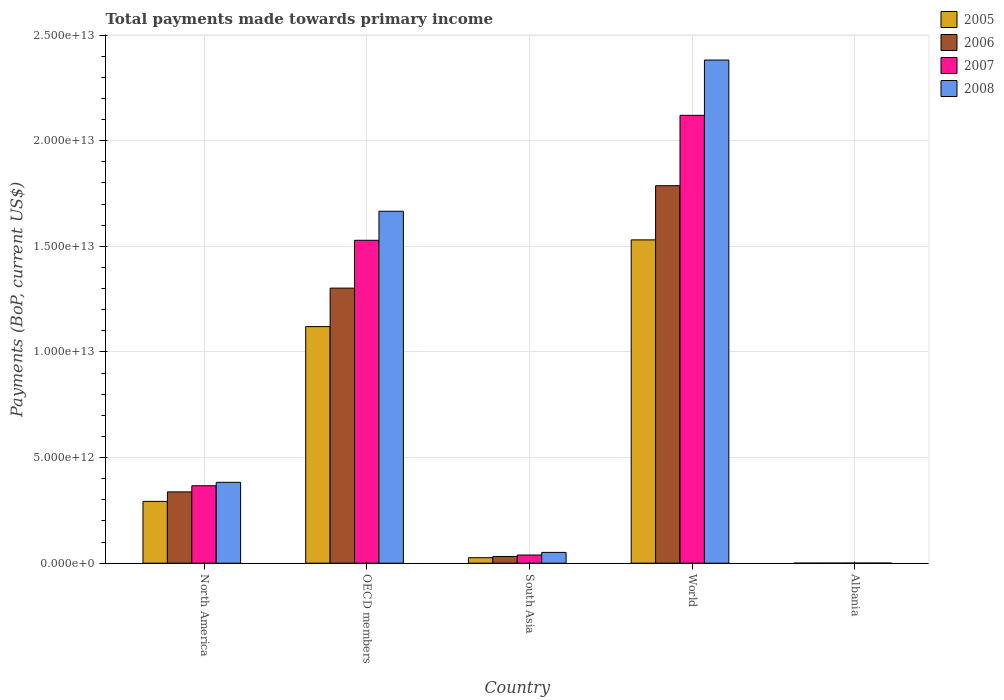How many different coloured bars are there?
Provide a short and direct response. 4. How many groups of bars are there?
Your response must be concise. 5. Are the number of bars per tick equal to the number of legend labels?
Provide a short and direct response. Yes. Are the number of bars on each tick of the X-axis equal?
Your response must be concise. Yes. How many bars are there on the 3rd tick from the left?
Ensure brevity in your answer.  4. How many bars are there on the 5th tick from the right?
Ensure brevity in your answer.  4. What is the label of the 1st group of bars from the left?
Give a very brief answer. North America. In how many cases, is the number of bars for a given country not equal to the number of legend labels?
Provide a succinct answer. 0. What is the total payments made towards primary income in 2007 in World?
Provide a succinct answer. 2.12e+13. Across all countries, what is the maximum total payments made towards primary income in 2005?
Offer a very short reply. 1.53e+13. Across all countries, what is the minimum total payments made towards primary income in 2006?
Offer a very short reply. 4.14e+09. In which country was the total payments made towards primary income in 2007 minimum?
Provide a short and direct response. Albania. What is the total total payments made towards primary income in 2006 in the graph?
Make the answer very short. 3.46e+13. What is the difference between the total payments made towards primary income in 2006 in Albania and that in OECD members?
Ensure brevity in your answer.  -1.30e+13. What is the difference between the total payments made towards primary income in 2007 in World and the total payments made towards primary income in 2006 in North America?
Give a very brief answer. 1.78e+13. What is the average total payments made towards primary income in 2006 per country?
Give a very brief answer. 6.92e+12. What is the difference between the total payments made towards primary income of/in 2007 and total payments made towards primary income of/in 2008 in OECD members?
Your answer should be very brief. -1.38e+12. In how many countries, is the total payments made towards primary income in 2005 greater than 1000000000000 US$?
Provide a short and direct response. 3. What is the ratio of the total payments made towards primary income in 2008 in North America to that in South Asia?
Your answer should be very brief. 7.49. Is the total payments made towards primary income in 2007 in OECD members less than that in World?
Your answer should be compact. Yes. What is the difference between the highest and the second highest total payments made towards primary income in 2007?
Provide a succinct answer. 1.75e+13. What is the difference between the highest and the lowest total payments made towards primary income in 2005?
Provide a short and direct response. 1.53e+13. Is it the case that in every country, the sum of the total payments made towards primary income in 2005 and total payments made towards primary income in 2008 is greater than the total payments made towards primary income in 2007?
Provide a short and direct response. Yes. What is the difference between two consecutive major ticks on the Y-axis?
Give a very brief answer. 5.00e+12. Does the graph contain any zero values?
Your answer should be very brief. No. Where does the legend appear in the graph?
Provide a short and direct response. Top right. What is the title of the graph?
Your answer should be very brief. Total payments made towards primary income. What is the label or title of the Y-axis?
Offer a very short reply. Payments (BoP, current US$). What is the Payments (BoP, current US$) of 2005 in North America?
Your answer should be very brief. 2.93e+12. What is the Payments (BoP, current US$) of 2006 in North America?
Provide a short and direct response. 3.38e+12. What is the Payments (BoP, current US$) of 2007 in North America?
Your answer should be compact. 3.67e+12. What is the Payments (BoP, current US$) in 2008 in North America?
Offer a very short reply. 3.83e+12. What is the Payments (BoP, current US$) in 2005 in OECD members?
Your response must be concise. 1.12e+13. What is the Payments (BoP, current US$) in 2006 in OECD members?
Provide a succinct answer. 1.30e+13. What is the Payments (BoP, current US$) of 2007 in OECD members?
Give a very brief answer. 1.53e+13. What is the Payments (BoP, current US$) of 2008 in OECD members?
Offer a very short reply. 1.67e+13. What is the Payments (BoP, current US$) in 2005 in South Asia?
Offer a very short reply. 2.61e+11. What is the Payments (BoP, current US$) of 2006 in South Asia?
Ensure brevity in your answer.  3.18e+11. What is the Payments (BoP, current US$) of 2007 in South Asia?
Your answer should be very brief. 3.88e+11. What is the Payments (BoP, current US$) in 2008 in South Asia?
Your answer should be compact. 5.11e+11. What is the Payments (BoP, current US$) of 2005 in World?
Offer a terse response. 1.53e+13. What is the Payments (BoP, current US$) of 2006 in World?
Offer a very short reply. 1.79e+13. What is the Payments (BoP, current US$) of 2007 in World?
Make the answer very short. 2.12e+13. What is the Payments (BoP, current US$) in 2008 in World?
Offer a terse response. 2.38e+13. What is the Payments (BoP, current US$) in 2005 in Albania?
Your response must be concise. 3.55e+09. What is the Payments (BoP, current US$) in 2006 in Albania?
Provide a succinct answer. 4.14e+09. What is the Payments (BoP, current US$) in 2007 in Albania?
Make the answer very short. 5.43e+09. What is the Payments (BoP, current US$) in 2008 in Albania?
Your answer should be compact. 7.15e+09. Across all countries, what is the maximum Payments (BoP, current US$) of 2005?
Provide a short and direct response. 1.53e+13. Across all countries, what is the maximum Payments (BoP, current US$) of 2006?
Your answer should be very brief. 1.79e+13. Across all countries, what is the maximum Payments (BoP, current US$) of 2007?
Provide a succinct answer. 2.12e+13. Across all countries, what is the maximum Payments (BoP, current US$) in 2008?
Give a very brief answer. 2.38e+13. Across all countries, what is the minimum Payments (BoP, current US$) of 2005?
Your answer should be compact. 3.55e+09. Across all countries, what is the minimum Payments (BoP, current US$) in 2006?
Keep it short and to the point. 4.14e+09. Across all countries, what is the minimum Payments (BoP, current US$) in 2007?
Give a very brief answer. 5.43e+09. Across all countries, what is the minimum Payments (BoP, current US$) in 2008?
Offer a very short reply. 7.15e+09. What is the total Payments (BoP, current US$) of 2005 in the graph?
Ensure brevity in your answer.  2.97e+13. What is the total Payments (BoP, current US$) in 2006 in the graph?
Provide a short and direct response. 3.46e+13. What is the total Payments (BoP, current US$) of 2007 in the graph?
Provide a succinct answer. 4.05e+13. What is the total Payments (BoP, current US$) in 2008 in the graph?
Ensure brevity in your answer.  4.48e+13. What is the difference between the Payments (BoP, current US$) in 2005 in North America and that in OECD members?
Your response must be concise. -8.27e+12. What is the difference between the Payments (BoP, current US$) in 2006 in North America and that in OECD members?
Your response must be concise. -9.65e+12. What is the difference between the Payments (BoP, current US$) in 2007 in North America and that in OECD members?
Offer a terse response. -1.16e+13. What is the difference between the Payments (BoP, current US$) in 2008 in North America and that in OECD members?
Your answer should be compact. -1.28e+13. What is the difference between the Payments (BoP, current US$) of 2005 in North America and that in South Asia?
Offer a terse response. 2.67e+12. What is the difference between the Payments (BoP, current US$) in 2006 in North America and that in South Asia?
Your response must be concise. 3.06e+12. What is the difference between the Payments (BoP, current US$) in 2007 in North America and that in South Asia?
Offer a terse response. 3.28e+12. What is the difference between the Payments (BoP, current US$) of 2008 in North America and that in South Asia?
Your response must be concise. 3.32e+12. What is the difference between the Payments (BoP, current US$) in 2005 in North America and that in World?
Give a very brief answer. -1.24e+13. What is the difference between the Payments (BoP, current US$) of 2006 in North America and that in World?
Provide a short and direct response. -1.45e+13. What is the difference between the Payments (BoP, current US$) in 2007 in North America and that in World?
Your answer should be very brief. -1.75e+13. What is the difference between the Payments (BoP, current US$) of 2008 in North America and that in World?
Make the answer very short. -2.00e+13. What is the difference between the Payments (BoP, current US$) in 2005 in North America and that in Albania?
Your answer should be compact. 2.92e+12. What is the difference between the Payments (BoP, current US$) in 2006 in North America and that in Albania?
Make the answer very short. 3.37e+12. What is the difference between the Payments (BoP, current US$) of 2007 in North America and that in Albania?
Your answer should be compact. 3.66e+12. What is the difference between the Payments (BoP, current US$) in 2008 in North America and that in Albania?
Give a very brief answer. 3.82e+12. What is the difference between the Payments (BoP, current US$) of 2005 in OECD members and that in South Asia?
Provide a short and direct response. 1.09e+13. What is the difference between the Payments (BoP, current US$) in 2006 in OECD members and that in South Asia?
Your answer should be compact. 1.27e+13. What is the difference between the Payments (BoP, current US$) of 2007 in OECD members and that in South Asia?
Your response must be concise. 1.49e+13. What is the difference between the Payments (BoP, current US$) of 2008 in OECD members and that in South Asia?
Offer a very short reply. 1.61e+13. What is the difference between the Payments (BoP, current US$) in 2005 in OECD members and that in World?
Your response must be concise. -4.11e+12. What is the difference between the Payments (BoP, current US$) in 2006 in OECD members and that in World?
Offer a very short reply. -4.85e+12. What is the difference between the Payments (BoP, current US$) of 2007 in OECD members and that in World?
Your answer should be compact. -5.91e+12. What is the difference between the Payments (BoP, current US$) in 2008 in OECD members and that in World?
Ensure brevity in your answer.  -7.16e+12. What is the difference between the Payments (BoP, current US$) in 2005 in OECD members and that in Albania?
Your answer should be very brief. 1.12e+13. What is the difference between the Payments (BoP, current US$) of 2006 in OECD members and that in Albania?
Your answer should be very brief. 1.30e+13. What is the difference between the Payments (BoP, current US$) in 2007 in OECD members and that in Albania?
Ensure brevity in your answer.  1.53e+13. What is the difference between the Payments (BoP, current US$) of 2008 in OECD members and that in Albania?
Offer a very short reply. 1.67e+13. What is the difference between the Payments (BoP, current US$) in 2005 in South Asia and that in World?
Your answer should be very brief. -1.50e+13. What is the difference between the Payments (BoP, current US$) of 2006 in South Asia and that in World?
Offer a very short reply. -1.75e+13. What is the difference between the Payments (BoP, current US$) of 2007 in South Asia and that in World?
Provide a succinct answer. -2.08e+13. What is the difference between the Payments (BoP, current US$) in 2008 in South Asia and that in World?
Provide a succinct answer. -2.33e+13. What is the difference between the Payments (BoP, current US$) in 2005 in South Asia and that in Albania?
Your response must be concise. 2.57e+11. What is the difference between the Payments (BoP, current US$) of 2006 in South Asia and that in Albania?
Provide a succinct answer. 3.14e+11. What is the difference between the Payments (BoP, current US$) in 2007 in South Asia and that in Albania?
Offer a terse response. 3.82e+11. What is the difference between the Payments (BoP, current US$) of 2008 in South Asia and that in Albania?
Give a very brief answer. 5.04e+11. What is the difference between the Payments (BoP, current US$) of 2005 in World and that in Albania?
Your answer should be compact. 1.53e+13. What is the difference between the Payments (BoP, current US$) of 2006 in World and that in Albania?
Give a very brief answer. 1.79e+13. What is the difference between the Payments (BoP, current US$) of 2007 in World and that in Albania?
Provide a short and direct response. 2.12e+13. What is the difference between the Payments (BoP, current US$) of 2008 in World and that in Albania?
Ensure brevity in your answer.  2.38e+13. What is the difference between the Payments (BoP, current US$) of 2005 in North America and the Payments (BoP, current US$) of 2006 in OECD members?
Your answer should be very brief. -1.01e+13. What is the difference between the Payments (BoP, current US$) in 2005 in North America and the Payments (BoP, current US$) in 2007 in OECD members?
Your answer should be compact. -1.24e+13. What is the difference between the Payments (BoP, current US$) of 2005 in North America and the Payments (BoP, current US$) of 2008 in OECD members?
Provide a short and direct response. -1.37e+13. What is the difference between the Payments (BoP, current US$) of 2006 in North America and the Payments (BoP, current US$) of 2007 in OECD members?
Your response must be concise. -1.19e+13. What is the difference between the Payments (BoP, current US$) in 2006 in North America and the Payments (BoP, current US$) in 2008 in OECD members?
Ensure brevity in your answer.  -1.33e+13. What is the difference between the Payments (BoP, current US$) in 2007 in North America and the Payments (BoP, current US$) in 2008 in OECD members?
Offer a terse response. -1.30e+13. What is the difference between the Payments (BoP, current US$) in 2005 in North America and the Payments (BoP, current US$) in 2006 in South Asia?
Your answer should be compact. 2.61e+12. What is the difference between the Payments (BoP, current US$) of 2005 in North America and the Payments (BoP, current US$) of 2007 in South Asia?
Keep it short and to the point. 2.54e+12. What is the difference between the Payments (BoP, current US$) in 2005 in North America and the Payments (BoP, current US$) in 2008 in South Asia?
Keep it short and to the point. 2.41e+12. What is the difference between the Payments (BoP, current US$) of 2006 in North America and the Payments (BoP, current US$) of 2007 in South Asia?
Provide a short and direct response. 2.99e+12. What is the difference between the Payments (BoP, current US$) in 2006 in North America and the Payments (BoP, current US$) in 2008 in South Asia?
Provide a succinct answer. 2.86e+12. What is the difference between the Payments (BoP, current US$) in 2007 in North America and the Payments (BoP, current US$) in 2008 in South Asia?
Your answer should be very brief. 3.15e+12. What is the difference between the Payments (BoP, current US$) in 2005 in North America and the Payments (BoP, current US$) in 2006 in World?
Your answer should be compact. -1.49e+13. What is the difference between the Payments (BoP, current US$) of 2005 in North America and the Payments (BoP, current US$) of 2007 in World?
Ensure brevity in your answer.  -1.83e+13. What is the difference between the Payments (BoP, current US$) of 2005 in North America and the Payments (BoP, current US$) of 2008 in World?
Offer a terse response. -2.09e+13. What is the difference between the Payments (BoP, current US$) of 2006 in North America and the Payments (BoP, current US$) of 2007 in World?
Provide a succinct answer. -1.78e+13. What is the difference between the Payments (BoP, current US$) of 2006 in North America and the Payments (BoP, current US$) of 2008 in World?
Ensure brevity in your answer.  -2.04e+13. What is the difference between the Payments (BoP, current US$) in 2007 in North America and the Payments (BoP, current US$) in 2008 in World?
Your response must be concise. -2.01e+13. What is the difference between the Payments (BoP, current US$) of 2005 in North America and the Payments (BoP, current US$) of 2006 in Albania?
Keep it short and to the point. 2.92e+12. What is the difference between the Payments (BoP, current US$) of 2005 in North America and the Payments (BoP, current US$) of 2007 in Albania?
Provide a succinct answer. 2.92e+12. What is the difference between the Payments (BoP, current US$) of 2005 in North America and the Payments (BoP, current US$) of 2008 in Albania?
Your response must be concise. 2.92e+12. What is the difference between the Payments (BoP, current US$) of 2006 in North America and the Payments (BoP, current US$) of 2007 in Albania?
Provide a short and direct response. 3.37e+12. What is the difference between the Payments (BoP, current US$) of 2006 in North America and the Payments (BoP, current US$) of 2008 in Albania?
Your answer should be very brief. 3.37e+12. What is the difference between the Payments (BoP, current US$) in 2007 in North America and the Payments (BoP, current US$) in 2008 in Albania?
Keep it short and to the point. 3.66e+12. What is the difference between the Payments (BoP, current US$) of 2005 in OECD members and the Payments (BoP, current US$) of 2006 in South Asia?
Offer a very short reply. 1.09e+13. What is the difference between the Payments (BoP, current US$) of 2005 in OECD members and the Payments (BoP, current US$) of 2007 in South Asia?
Keep it short and to the point. 1.08e+13. What is the difference between the Payments (BoP, current US$) of 2005 in OECD members and the Payments (BoP, current US$) of 2008 in South Asia?
Your answer should be compact. 1.07e+13. What is the difference between the Payments (BoP, current US$) of 2006 in OECD members and the Payments (BoP, current US$) of 2007 in South Asia?
Your answer should be compact. 1.26e+13. What is the difference between the Payments (BoP, current US$) of 2006 in OECD members and the Payments (BoP, current US$) of 2008 in South Asia?
Your answer should be compact. 1.25e+13. What is the difference between the Payments (BoP, current US$) in 2007 in OECD members and the Payments (BoP, current US$) in 2008 in South Asia?
Ensure brevity in your answer.  1.48e+13. What is the difference between the Payments (BoP, current US$) of 2005 in OECD members and the Payments (BoP, current US$) of 2006 in World?
Your answer should be compact. -6.67e+12. What is the difference between the Payments (BoP, current US$) of 2005 in OECD members and the Payments (BoP, current US$) of 2007 in World?
Keep it short and to the point. -1.00e+13. What is the difference between the Payments (BoP, current US$) of 2005 in OECD members and the Payments (BoP, current US$) of 2008 in World?
Provide a succinct answer. -1.26e+13. What is the difference between the Payments (BoP, current US$) of 2006 in OECD members and the Payments (BoP, current US$) of 2007 in World?
Your response must be concise. -8.18e+12. What is the difference between the Payments (BoP, current US$) of 2006 in OECD members and the Payments (BoP, current US$) of 2008 in World?
Provide a succinct answer. -1.08e+13. What is the difference between the Payments (BoP, current US$) of 2007 in OECD members and the Payments (BoP, current US$) of 2008 in World?
Your response must be concise. -8.53e+12. What is the difference between the Payments (BoP, current US$) of 2005 in OECD members and the Payments (BoP, current US$) of 2006 in Albania?
Your response must be concise. 1.12e+13. What is the difference between the Payments (BoP, current US$) of 2005 in OECD members and the Payments (BoP, current US$) of 2007 in Albania?
Ensure brevity in your answer.  1.12e+13. What is the difference between the Payments (BoP, current US$) of 2005 in OECD members and the Payments (BoP, current US$) of 2008 in Albania?
Your response must be concise. 1.12e+13. What is the difference between the Payments (BoP, current US$) of 2006 in OECD members and the Payments (BoP, current US$) of 2007 in Albania?
Make the answer very short. 1.30e+13. What is the difference between the Payments (BoP, current US$) of 2006 in OECD members and the Payments (BoP, current US$) of 2008 in Albania?
Offer a terse response. 1.30e+13. What is the difference between the Payments (BoP, current US$) of 2007 in OECD members and the Payments (BoP, current US$) of 2008 in Albania?
Provide a succinct answer. 1.53e+13. What is the difference between the Payments (BoP, current US$) in 2005 in South Asia and the Payments (BoP, current US$) in 2006 in World?
Ensure brevity in your answer.  -1.76e+13. What is the difference between the Payments (BoP, current US$) in 2005 in South Asia and the Payments (BoP, current US$) in 2007 in World?
Offer a very short reply. -2.09e+13. What is the difference between the Payments (BoP, current US$) in 2005 in South Asia and the Payments (BoP, current US$) in 2008 in World?
Give a very brief answer. -2.36e+13. What is the difference between the Payments (BoP, current US$) of 2006 in South Asia and the Payments (BoP, current US$) of 2007 in World?
Provide a succinct answer. -2.09e+13. What is the difference between the Payments (BoP, current US$) in 2006 in South Asia and the Payments (BoP, current US$) in 2008 in World?
Your answer should be very brief. -2.35e+13. What is the difference between the Payments (BoP, current US$) in 2007 in South Asia and the Payments (BoP, current US$) in 2008 in World?
Provide a succinct answer. -2.34e+13. What is the difference between the Payments (BoP, current US$) of 2005 in South Asia and the Payments (BoP, current US$) of 2006 in Albania?
Provide a succinct answer. 2.56e+11. What is the difference between the Payments (BoP, current US$) of 2005 in South Asia and the Payments (BoP, current US$) of 2007 in Albania?
Provide a short and direct response. 2.55e+11. What is the difference between the Payments (BoP, current US$) of 2005 in South Asia and the Payments (BoP, current US$) of 2008 in Albania?
Your answer should be compact. 2.53e+11. What is the difference between the Payments (BoP, current US$) of 2006 in South Asia and the Payments (BoP, current US$) of 2007 in Albania?
Your response must be concise. 3.13e+11. What is the difference between the Payments (BoP, current US$) of 2006 in South Asia and the Payments (BoP, current US$) of 2008 in Albania?
Your answer should be compact. 3.11e+11. What is the difference between the Payments (BoP, current US$) in 2007 in South Asia and the Payments (BoP, current US$) in 2008 in Albania?
Your response must be concise. 3.80e+11. What is the difference between the Payments (BoP, current US$) in 2005 in World and the Payments (BoP, current US$) in 2006 in Albania?
Ensure brevity in your answer.  1.53e+13. What is the difference between the Payments (BoP, current US$) of 2005 in World and the Payments (BoP, current US$) of 2007 in Albania?
Your answer should be very brief. 1.53e+13. What is the difference between the Payments (BoP, current US$) in 2005 in World and the Payments (BoP, current US$) in 2008 in Albania?
Your answer should be very brief. 1.53e+13. What is the difference between the Payments (BoP, current US$) of 2006 in World and the Payments (BoP, current US$) of 2007 in Albania?
Your answer should be compact. 1.79e+13. What is the difference between the Payments (BoP, current US$) in 2006 in World and the Payments (BoP, current US$) in 2008 in Albania?
Ensure brevity in your answer.  1.79e+13. What is the difference between the Payments (BoP, current US$) in 2007 in World and the Payments (BoP, current US$) in 2008 in Albania?
Ensure brevity in your answer.  2.12e+13. What is the average Payments (BoP, current US$) in 2005 per country?
Provide a short and direct response. 5.94e+12. What is the average Payments (BoP, current US$) in 2006 per country?
Keep it short and to the point. 6.92e+12. What is the average Payments (BoP, current US$) in 2007 per country?
Give a very brief answer. 8.11e+12. What is the average Payments (BoP, current US$) in 2008 per country?
Your answer should be compact. 8.96e+12. What is the difference between the Payments (BoP, current US$) of 2005 and Payments (BoP, current US$) of 2006 in North America?
Your answer should be very brief. -4.49e+11. What is the difference between the Payments (BoP, current US$) of 2005 and Payments (BoP, current US$) of 2007 in North America?
Provide a succinct answer. -7.40e+11. What is the difference between the Payments (BoP, current US$) in 2005 and Payments (BoP, current US$) in 2008 in North America?
Offer a terse response. -9.02e+11. What is the difference between the Payments (BoP, current US$) in 2006 and Payments (BoP, current US$) in 2007 in North America?
Keep it short and to the point. -2.91e+11. What is the difference between the Payments (BoP, current US$) in 2006 and Payments (BoP, current US$) in 2008 in North America?
Your answer should be compact. -4.53e+11. What is the difference between the Payments (BoP, current US$) of 2007 and Payments (BoP, current US$) of 2008 in North America?
Your response must be concise. -1.62e+11. What is the difference between the Payments (BoP, current US$) of 2005 and Payments (BoP, current US$) of 2006 in OECD members?
Provide a short and direct response. -1.82e+12. What is the difference between the Payments (BoP, current US$) in 2005 and Payments (BoP, current US$) in 2007 in OECD members?
Make the answer very short. -4.09e+12. What is the difference between the Payments (BoP, current US$) of 2005 and Payments (BoP, current US$) of 2008 in OECD members?
Keep it short and to the point. -5.46e+12. What is the difference between the Payments (BoP, current US$) in 2006 and Payments (BoP, current US$) in 2007 in OECD members?
Your response must be concise. -2.26e+12. What is the difference between the Payments (BoP, current US$) in 2006 and Payments (BoP, current US$) in 2008 in OECD members?
Ensure brevity in your answer.  -3.64e+12. What is the difference between the Payments (BoP, current US$) in 2007 and Payments (BoP, current US$) in 2008 in OECD members?
Make the answer very short. -1.38e+12. What is the difference between the Payments (BoP, current US$) in 2005 and Payments (BoP, current US$) in 2006 in South Asia?
Keep it short and to the point. -5.75e+1. What is the difference between the Payments (BoP, current US$) in 2005 and Payments (BoP, current US$) in 2007 in South Asia?
Provide a short and direct response. -1.27e+11. What is the difference between the Payments (BoP, current US$) in 2005 and Payments (BoP, current US$) in 2008 in South Asia?
Keep it short and to the point. -2.51e+11. What is the difference between the Payments (BoP, current US$) of 2006 and Payments (BoP, current US$) of 2007 in South Asia?
Your answer should be compact. -6.95e+1. What is the difference between the Payments (BoP, current US$) of 2006 and Payments (BoP, current US$) of 2008 in South Asia?
Your answer should be very brief. -1.93e+11. What is the difference between the Payments (BoP, current US$) of 2007 and Payments (BoP, current US$) of 2008 in South Asia?
Keep it short and to the point. -1.24e+11. What is the difference between the Payments (BoP, current US$) of 2005 and Payments (BoP, current US$) of 2006 in World?
Keep it short and to the point. -2.56e+12. What is the difference between the Payments (BoP, current US$) in 2005 and Payments (BoP, current US$) in 2007 in World?
Your answer should be very brief. -5.89e+12. What is the difference between the Payments (BoP, current US$) in 2005 and Payments (BoP, current US$) in 2008 in World?
Offer a very short reply. -8.51e+12. What is the difference between the Payments (BoP, current US$) in 2006 and Payments (BoP, current US$) in 2007 in World?
Your answer should be compact. -3.33e+12. What is the difference between the Payments (BoP, current US$) of 2006 and Payments (BoP, current US$) of 2008 in World?
Offer a very short reply. -5.95e+12. What is the difference between the Payments (BoP, current US$) of 2007 and Payments (BoP, current US$) of 2008 in World?
Give a very brief answer. -2.62e+12. What is the difference between the Payments (BoP, current US$) in 2005 and Payments (BoP, current US$) in 2006 in Albania?
Offer a very short reply. -5.89e+08. What is the difference between the Payments (BoP, current US$) in 2005 and Payments (BoP, current US$) in 2007 in Albania?
Offer a terse response. -1.88e+09. What is the difference between the Payments (BoP, current US$) of 2005 and Payments (BoP, current US$) of 2008 in Albania?
Keep it short and to the point. -3.60e+09. What is the difference between the Payments (BoP, current US$) of 2006 and Payments (BoP, current US$) of 2007 in Albania?
Your answer should be very brief. -1.29e+09. What is the difference between the Payments (BoP, current US$) of 2006 and Payments (BoP, current US$) of 2008 in Albania?
Offer a very short reply. -3.01e+09. What is the difference between the Payments (BoP, current US$) in 2007 and Payments (BoP, current US$) in 2008 in Albania?
Ensure brevity in your answer.  -1.72e+09. What is the ratio of the Payments (BoP, current US$) of 2005 in North America to that in OECD members?
Ensure brevity in your answer.  0.26. What is the ratio of the Payments (BoP, current US$) of 2006 in North America to that in OECD members?
Your answer should be very brief. 0.26. What is the ratio of the Payments (BoP, current US$) of 2007 in North America to that in OECD members?
Provide a short and direct response. 0.24. What is the ratio of the Payments (BoP, current US$) in 2008 in North America to that in OECD members?
Keep it short and to the point. 0.23. What is the ratio of the Payments (BoP, current US$) in 2005 in North America to that in South Asia?
Provide a succinct answer. 11.23. What is the ratio of the Payments (BoP, current US$) in 2006 in North America to that in South Asia?
Offer a very short reply. 10.61. What is the ratio of the Payments (BoP, current US$) of 2007 in North America to that in South Asia?
Your response must be concise. 9.46. What is the ratio of the Payments (BoP, current US$) of 2008 in North America to that in South Asia?
Your answer should be very brief. 7.49. What is the ratio of the Payments (BoP, current US$) of 2005 in North America to that in World?
Provide a short and direct response. 0.19. What is the ratio of the Payments (BoP, current US$) of 2006 in North America to that in World?
Keep it short and to the point. 0.19. What is the ratio of the Payments (BoP, current US$) in 2007 in North America to that in World?
Make the answer very short. 0.17. What is the ratio of the Payments (BoP, current US$) in 2008 in North America to that in World?
Make the answer very short. 0.16. What is the ratio of the Payments (BoP, current US$) in 2005 in North America to that in Albania?
Ensure brevity in your answer.  823.59. What is the ratio of the Payments (BoP, current US$) in 2006 in North America to that in Albania?
Make the answer very short. 814.9. What is the ratio of the Payments (BoP, current US$) of 2007 in North America to that in Albania?
Offer a terse response. 675.24. What is the ratio of the Payments (BoP, current US$) of 2008 in North America to that in Albania?
Give a very brief answer. 535.52. What is the ratio of the Payments (BoP, current US$) in 2005 in OECD members to that in South Asia?
Your answer should be very brief. 42.99. What is the ratio of the Payments (BoP, current US$) in 2006 in OECD members to that in South Asia?
Ensure brevity in your answer.  40.95. What is the ratio of the Payments (BoP, current US$) of 2007 in OECD members to that in South Asia?
Keep it short and to the point. 39.44. What is the ratio of the Payments (BoP, current US$) in 2008 in OECD members to that in South Asia?
Give a very brief answer. 32.59. What is the ratio of the Payments (BoP, current US$) in 2005 in OECD members to that in World?
Keep it short and to the point. 0.73. What is the ratio of the Payments (BoP, current US$) in 2006 in OECD members to that in World?
Your answer should be compact. 0.73. What is the ratio of the Payments (BoP, current US$) of 2007 in OECD members to that in World?
Give a very brief answer. 0.72. What is the ratio of the Payments (BoP, current US$) of 2008 in OECD members to that in World?
Your answer should be compact. 0.7. What is the ratio of the Payments (BoP, current US$) in 2005 in OECD members to that in Albania?
Your answer should be compact. 3151.7. What is the ratio of the Payments (BoP, current US$) in 2006 in OECD members to that in Albania?
Provide a short and direct response. 3143.4. What is the ratio of the Payments (BoP, current US$) in 2007 in OECD members to that in Albania?
Your answer should be compact. 2815.12. What is the ratio of the Payments (BoP, current US$) of 2008 in OECD members to that in Albania?
Ensure brevity in your answer.  2330.28. What is the ratio of the Payments (BoP, current US$) of 2005 in South Asia to that in World?
Keep it short and to the point. 0.02. What is the ratio of the Payments (BoP, current US$) of 2006 in South Asia to that in World?
Your answer should be very brief. 0.02. What is the ratio of the Payments (BoP, current US$) in 2007 in South Asia to that in World?
Ensure brevity in your answer.  0.02. What is the ratio of the Payments (BoP, current US$) in 2008 in South Asia to that in World?
Keep it short and to the point. 0.02. What is the ratio of the Payments (BoP, current US$) of 2005 in South Asia to that in Albania?
Offer a terse response. 73.32. What is the ratio of the Payments (BoP, current US$) in 2006 in South Asia to that in Albania?
Give a very brief answer. 76.77. What is the ratio of the Payments (BoP, current US$) in 2007 in South Asia to that in Albania?
Give a very brief answer. 71.38. What is the ratio of the Payments (BoP, current US$) of 2008 in South Asia to that in Albania?
Your answer should be compact. 71.51. What is the ratio of the Payments (BoP, current US$) in 2005 in World to that in Albania?
Keep it short and to the point. 4307.27. What is the ratio of the Payments (BoP, current US$) of 2006 in World to that in Albania?
Offer a very short reply. 4313.61. What is the ratio of the Payments (BoP, current US$) of 2007 in World to that in Albania?
Keep it short and to the point. 3904.49. What is the ratio of the Payments (BoP, current US$) of 2008 in World to that in Albania?
Your answer should be compact. 3331.38. What is the difference between the highest and the second highest Payments (BoP, current US$) in 2005?
Your answer should be compact. 4.11e+12. What is the difference between the highest and the second highest Payments (BoP, current US$) of 2006?
Offer a terse response. 4.85e+12. What is the difference between the highest and the second highest Payments (BoP, current US$) of 2007?
Provide a short and direct response. 5.91e+12. What is the difference between the highest and the second highest Payments (BoP, current US$) in 2008?
Provide a short and direct response. 7.16e+12. What is the difference between the highest and the lowest Payments (BoP, current US$) of 2005?
Provide a succinct answer. 1.53e+13. What is the difference between the highest and the lowest Payments (BoP, current US$) in 2006?
Give a very brief answer. 1.79e+13. What is the difference between the highest and the lowest Payments (BoP, current US$) in 2007?
Ensure brevity in your answer.  2.12e+13. What is the difference between the highest and the lowest Payments (BoP, current US$) of 2008?
Make the answer very short. 2.38e+13. 